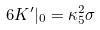<formula> <loc_0><loc_0><loc_500><loc_500>6 K ^ { \prime } | _ { 0 } = \kappa _ { 5 } ^ { 2 } \sigma</formula> 